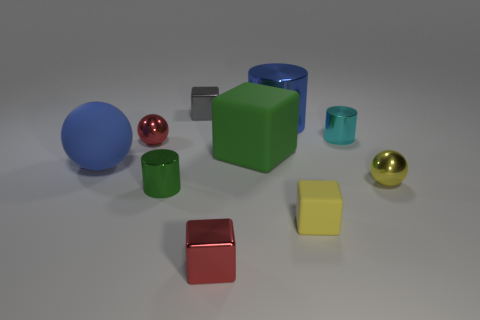There is a object that is both behind the green matte thing and left of the tiny gray block; what is its color?
Give a very brief answer. Red. What number of blue spheres have the same size as the yellow sphere?
Your answer should be compact. 0. What is the shape of the small red metal object in front of the small ball that is in front of the tiny red sphere?
Offer a terse response. Cube. What shape is the blue object in front of the ball behind the large blue object to the left of the small red cube?
Make the answer very short. Sphere. How many other yellow objects are the same shape as the yellow matte thing?
Your answer should be very brief. 0. There is a small metallic cylinder right of the tiny matte object; how many green metal cylinders are in front of it?
Offer a very short reply. 1. What number of rubber objects are either big things or green cylinders?
Give a very brief answer. 2. Is there a cyan ball made of the same material as the small gray thing?
Ensure brevity in your answer.  No. How many objects are either small objects in front of the green cylinder or shiny objects that are behind the tiny green shiny thing?
Your answer should be very brief. 7. Does the tiny shiny ball in front of the blue matte object have the same color as the small matte block?
Provide a succinct answer. Yes. 